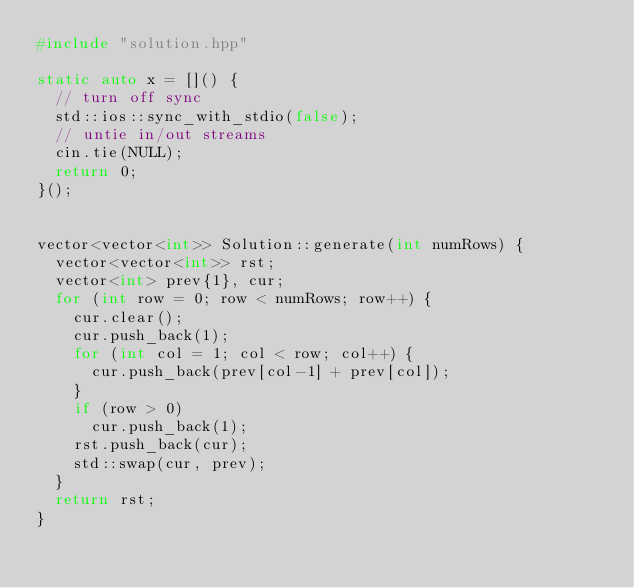Convert code to text. <code><loc_0><loc_0><loc_500><loc_500><_C++_>#include "solution.hpp"

static auto x = []() {
	// turn off sync
	std::ios::sync_with_stdio(false);
	// untie in/out streams
	cin.tie(NULL);
	return 0;
}();


vector<vector<int>> Solution::generate(int numRows) {
	vector<vector<int>> rst;
	vector<int> prev{1}, cur;
	for (int row = 0; row < numRows; row++) {
		cur.clear();
		cur.push_back(1);
		for (int col = 1; col < row; col++) {
			cur.push_back(prev[col-1] + prev[col]);
		}
		if (row > 0)
			cur.push_back(1);
		rst.push_back(cur);
		std::swap(cur, prev);
	}
	return rst;
}
</code> 